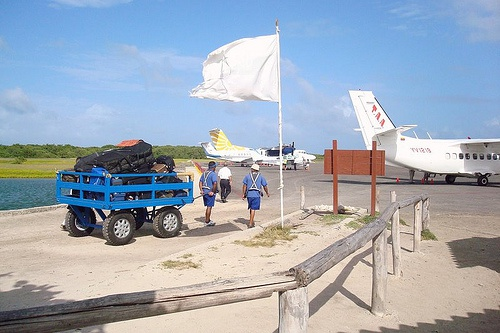Describe the objects in this image and their specific colors. I can see airplane in gray, white, darkgray, and black tones, airplane in gray, white, khaki, and darkgray tones, people in gray, darkgray, and lightgray tones, people in gray, navy, and darkgray tones, and airplane in gray, white, darkgray, and black tones in this image. 